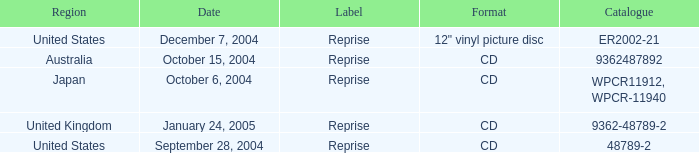Name the label for january 24, 2005 Reprise. 